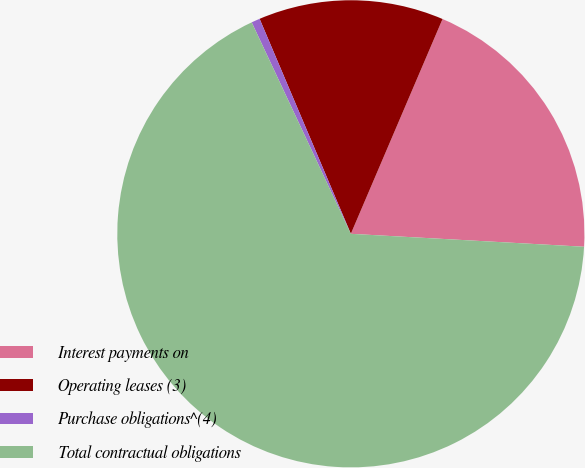Convert chart. <chart><loc_0><loc_0><loc_500><loc_500><pie_chart><fcel>Interest payments on<fcel>Operating leases (3)<fcel>Purchase obligations^(4)<fcel>Total contractual obligations<nl><fcel>19.46%<fcel>12.81%<fcel>0.59%<fcel>67.14%<nl></chart> 